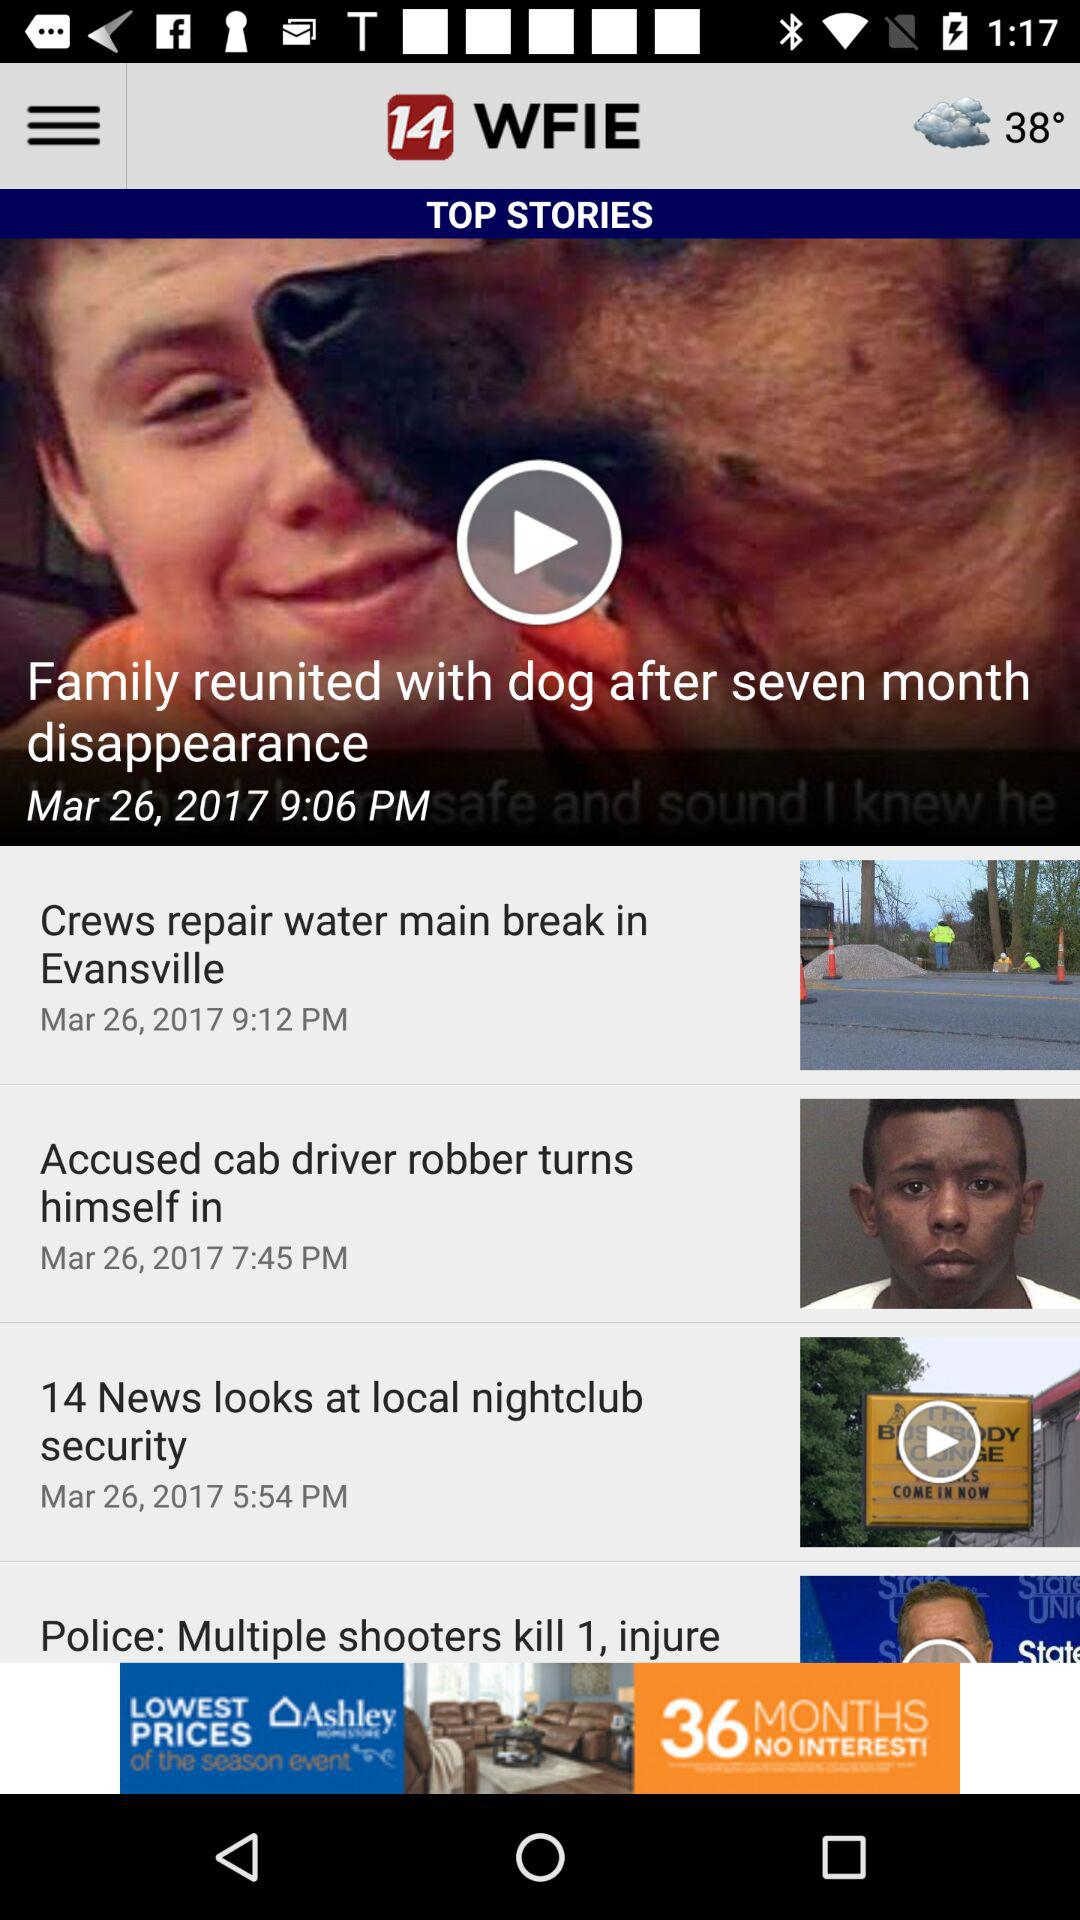On what date is the news "Family reunited with dog after seven month disappearance" updated? The updated date is March 26, 2017. 